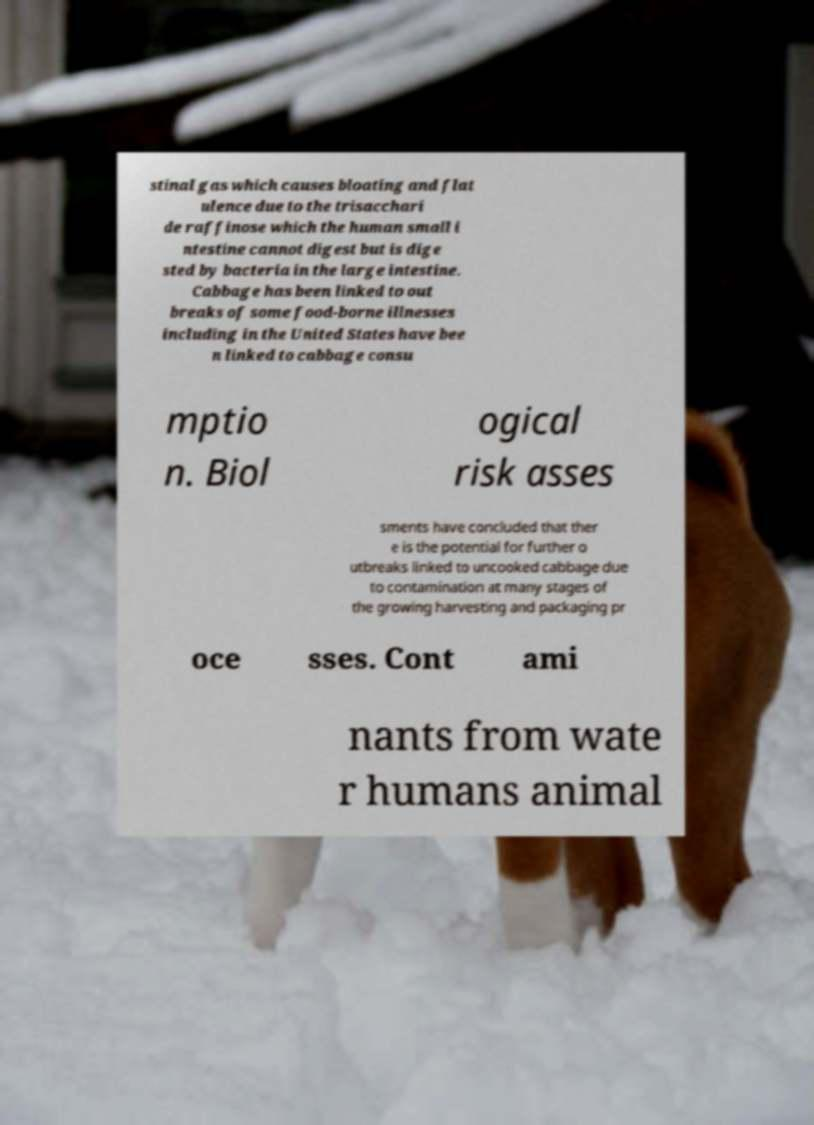Please identify and transcribe the text found in this image. stinal gas which causes bloating and flat ulence due to the trisacchari de raffinose which the human small i ntestine cannot digest but is dige sted by bacteria in the large intestine. Cabbage has been linked to out breaks of some food-borne illnesses including in the United States have bee n linked to cabbage consu mptio n. Biol ogical risk asses sments have concluded that ther e is the potential for further o utbreaks linked to uncooked cabbage due to contamination at many stages of the growing harvesting and packaging pr oce sses. Cont ami nants from wate r humans animal 